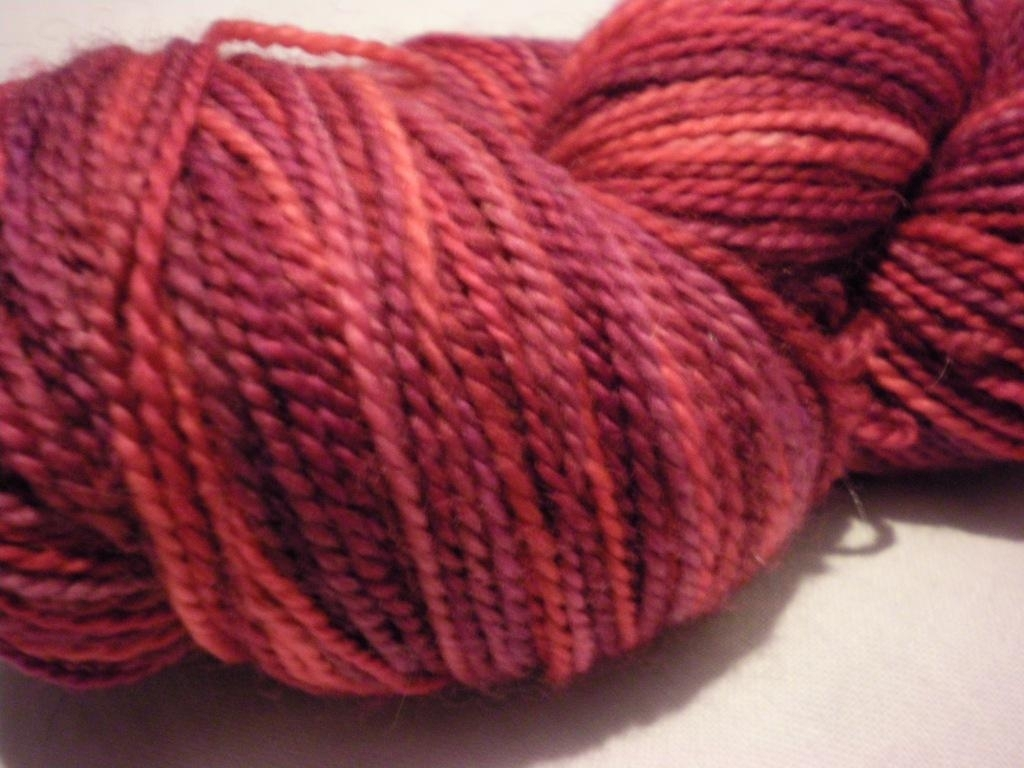Describe the colors present in the image. The image showcases a skein of yarn featuring rich shades of red and burgundy, with subtle variations that create a marbled or heathered effect. This adds depth and character to the yarn, making it ideal for creating visually interesting textile projects. 